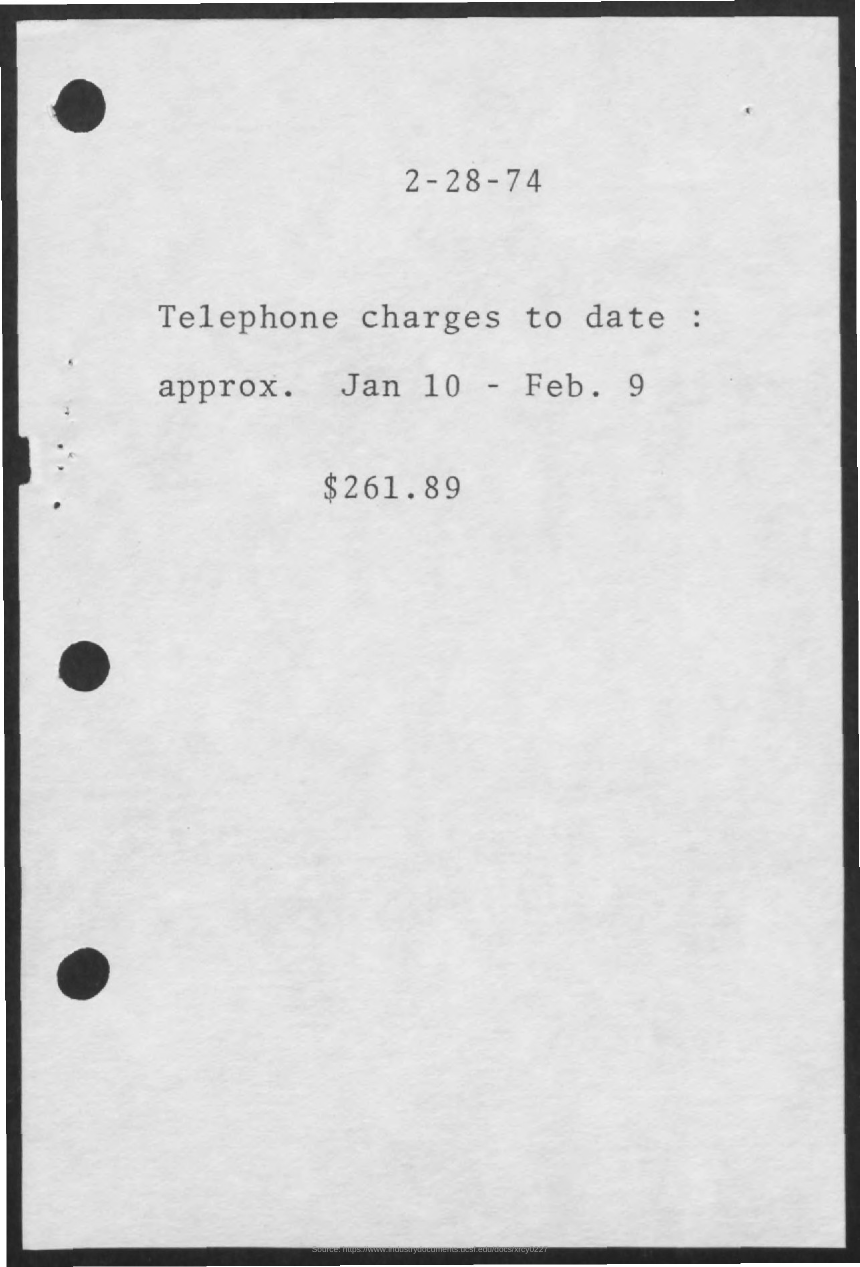Can you provide details on the date seen in the document? The document is dated February 28, 1974, which likely indicates when the statement for the telephone charges was issued or recorded. 